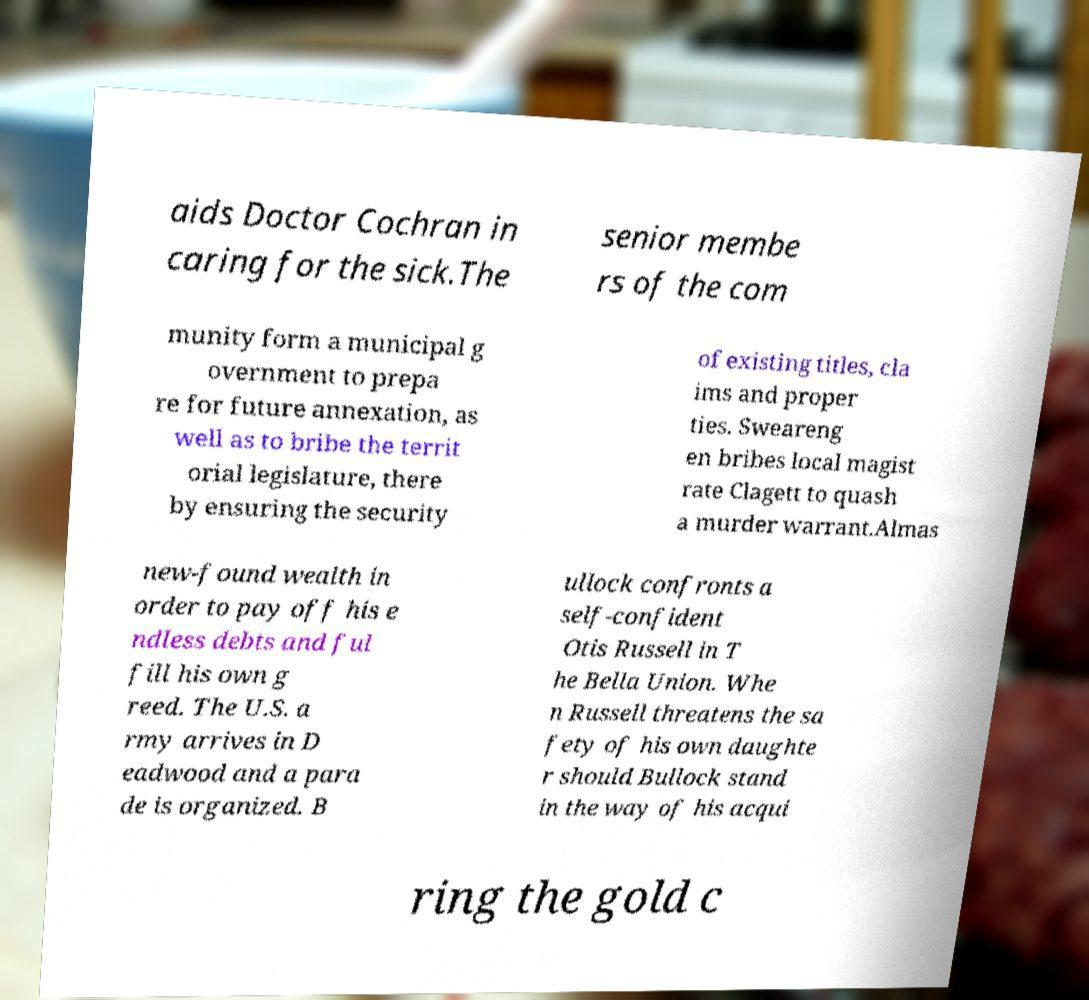Can you accurately transcribe the text from the provided image for me? aids Doctor Cochran in caring for the sick.The senior membe rs of the com munity form a municipal g overnment to prepa re for future annexation, as well as to bribe the territ orial legislature, there by ensuring the security of existing titles, cla ims and proper ties. Sweareng en bribes local magist rate Clagett to quash a murder warrant.Almas new-found wealth in order to pay off his e ndless debts and ful fill his own g reed. The U.S. a rmy arrives in D eadwood and a para de is organized. B ullock confronts a self-confident Otis Russell in T he Bella Union. Whe n Russell threatens the sa fety of his own daughte r should Bullock stand in the way of his acqui ring the gold c 